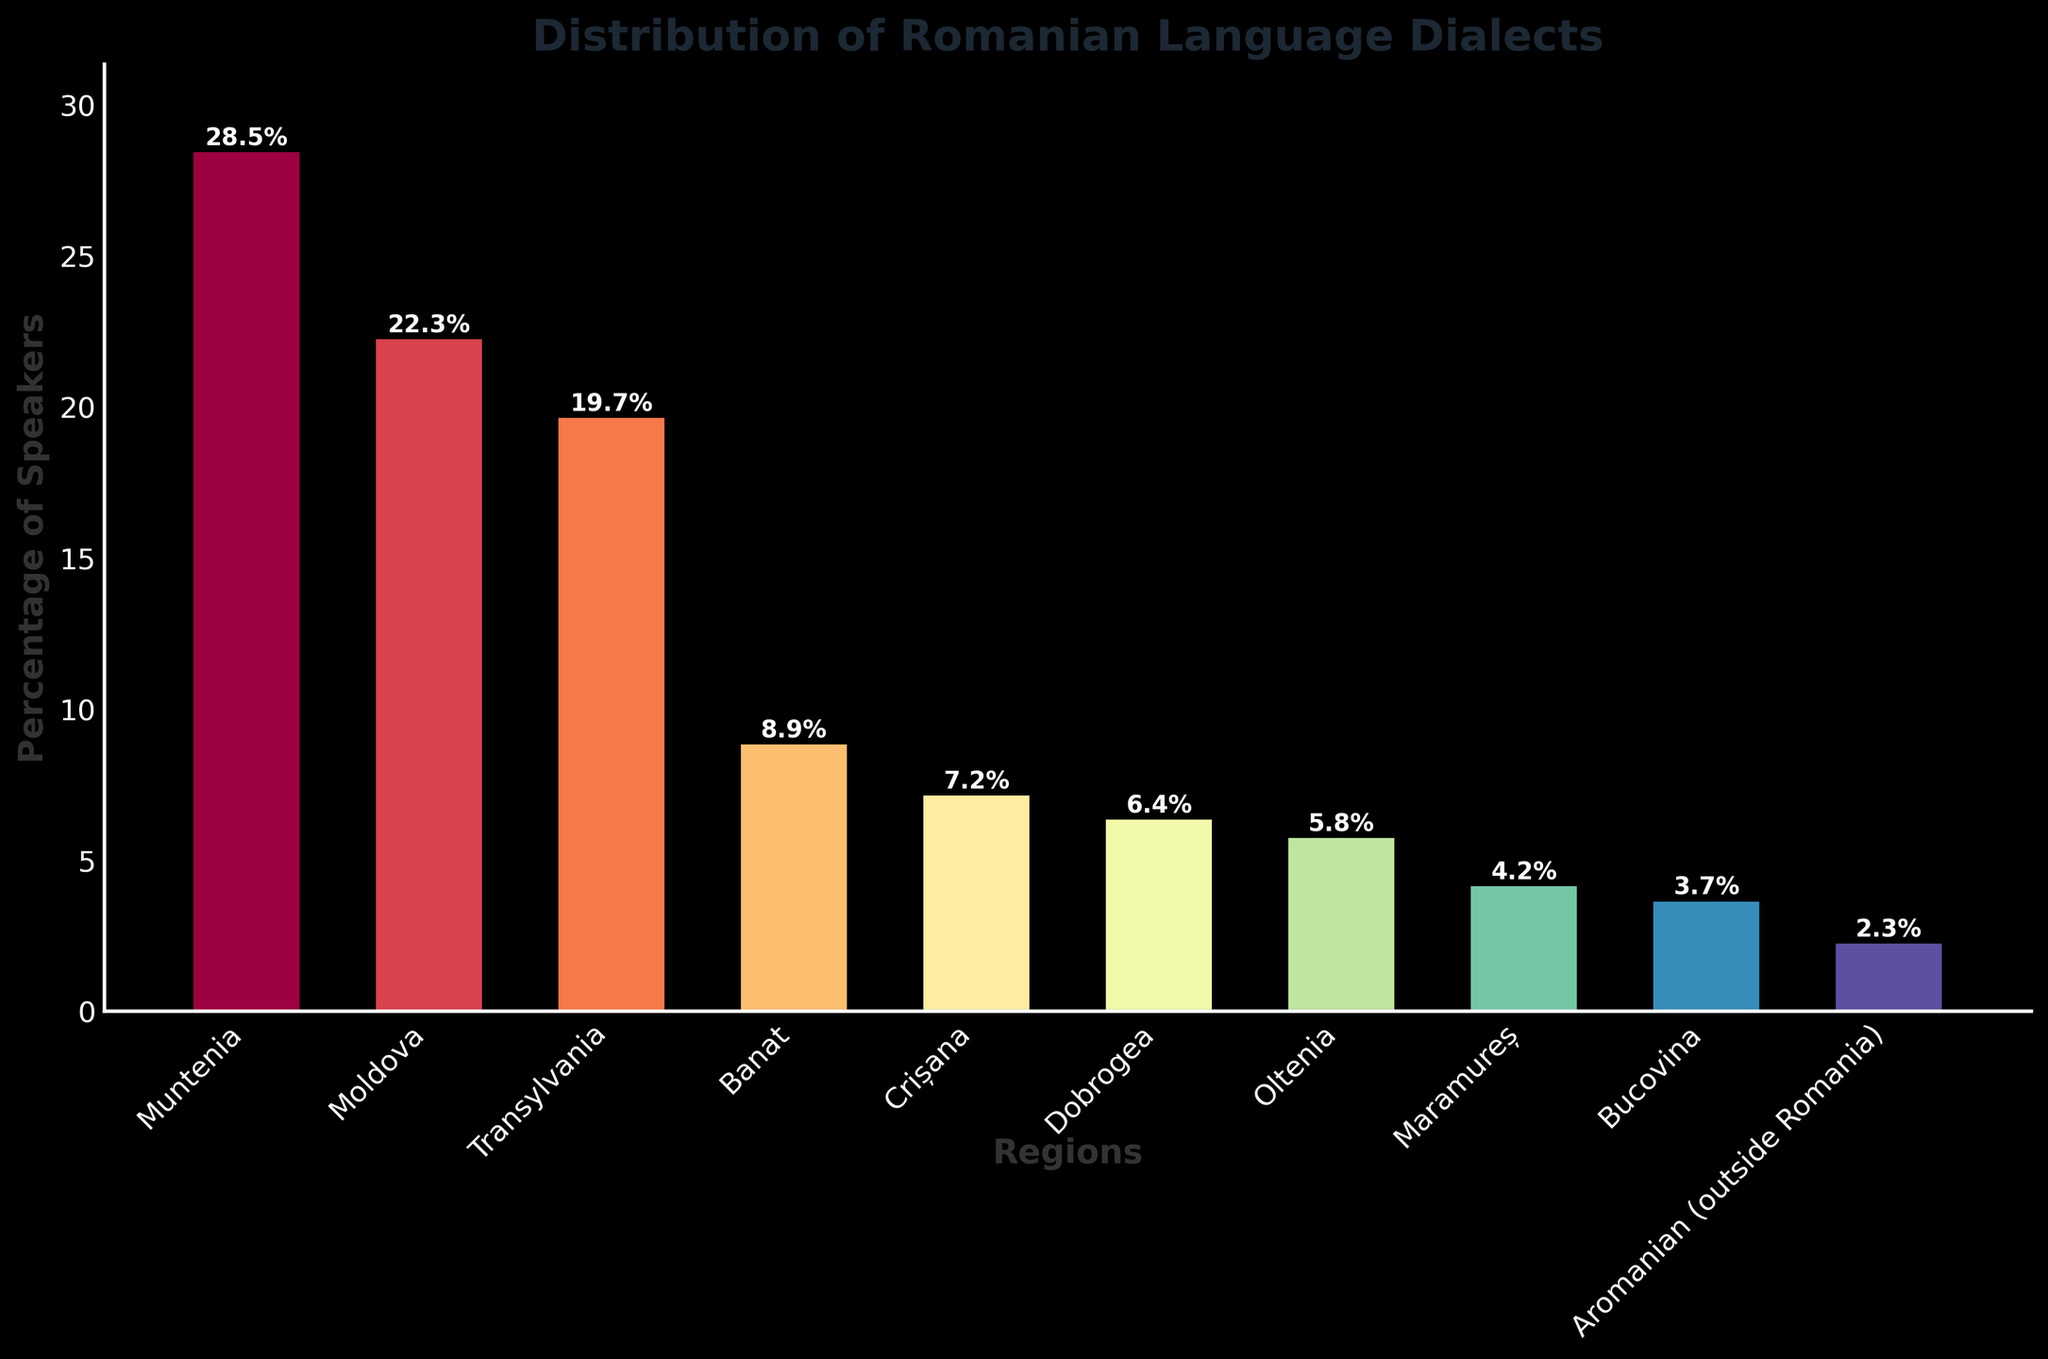Which region has the highest percentage of Romanian language speakers? By observing the height of the bars, Muntenia has the tallest bar, representing the highest percentage of speakers at 28.5%.
Answer: Muntenia Which region has a lower percentage of speakers, Crișana or Dobrogea? Comparing the heights of the bars for Crișana and Dobrogea, Crișana's bar is slightly taller at 7.2%, while Dobrogea's bar stands at 6.4%.
Answer: Dobrogea What is the combined percentage of speakers for Banat and Oltenia? To find the combined percentage, sum the values for Banat (8.9%) and Oltenia (5.8%). The total is 8.9 + 5.8 = 14.7%.
Answer: 14.7% Which region has approximately half the percentage of Muntenia? Muntenia has 28.5%. Approximately half of 28.5% is around 14.25%. The closest region is Banat with 8.9%, though it is not a perfect half.
Answer: Banat If the percentages for Maramureș and Bucovina are combined, do they surpass Dobrogea's percentage? Maramureș has 4.2% and Bucovina has 3.7%. Summing these values, 4.2 + 3.7 = 7.9%, which is higher than Dobrogea's 6.4%.
Answer: Yes What is the total percentage of speakers in Moldova, Transylvania, and Banat combined? Summing the percentages for Moldova (22.3%), Transylvania (19.7%), and Banat (8.9%): 22.3 + 19.7 + 8.9 = 50.9%.
Answer: 50.9% Which regions have a percentage of speakers below 5%? Reviewing the chart, Maramureș (4.2%), Bucovina (3.7%), and Aromanian (outside Romania) (2.3%) have percentages below 5%.
Answer: Maramureș, Bucovina, Aromanian (outside Romania) Which region's percentage is closest to the average percentage of all regions? First, calculate the average: (28.5 + 22.3 + 19.7 + 8.9 + 7.2 + 6.4 + 5.8 + 4.2 + 3.7 + 2.3) / 10 = 10.9%. The region closest to this average is Crișana with 7.2%.
Answer: Crișana 